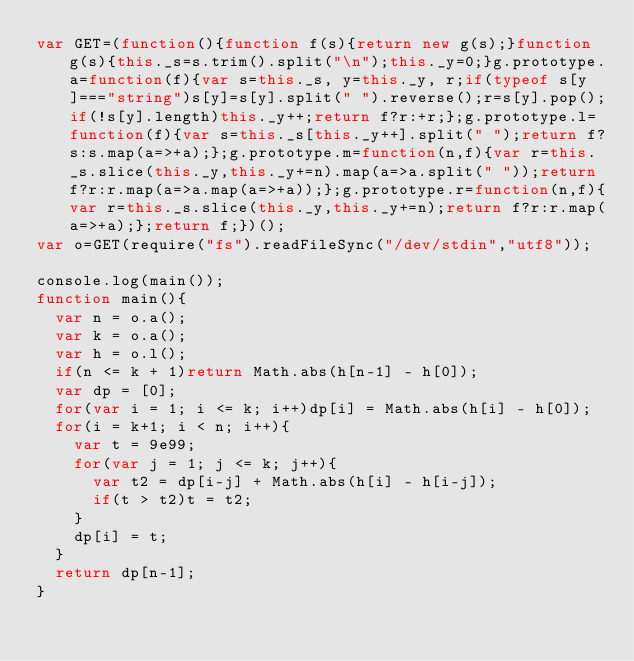<code> <loc_0><loc_0><loc_500><loc_500><_JavaScript_>var GET=(function(){function f(s){return new g(s);}function g(s){this._s=s.trim().split("\n");this._y=0;}g.prototype.a=function(f){var s=this._s, y=this._y, r;if(typeof s[y]==="string")s[y]=s[y].split(" ").reverse();r=s[y].pop();if(!s[y].length)this._y++;return f?r:+r;};g.prototype.l=function(f){var s=this._s[this._y++].split(" ");return f?s:s.map(a=>+a);};g.prototype.m=function(n,f){var r=this._s.slice(this._y,this._y+=n).map(a=>a.split(" "));return f?r:r.map(a=>a.map(a=>+a));};g.prototype.r=function(n,f){var r=this._s.slice(this._y,this._y+=n);return f?r:r.map(a=>+a);};return f;})();
var o=GET(require("fs").readFileSync("/dev/stdin","utf8"));

console.log(main());
function main(){
  var n = o.a();
  var k = o.a();
  var h = o.l();
  if(n <= k + 1)return Math.abs(h[n-1] - h[0]);
  var dp = [0];
  for(var i = 1; i <= k; i++)dp[i] = Math.abs(h[i] - h[0]);
  for(i = k+1; i < n; i++){
    var t = 9e99;
    for(var j = 1; j <= k; j++){
      var t2 = dp[i-j] + Math.abs(h[i] - h[i-j]);
      if(t > t2)t = t2;
    }
    dp[i] = t;
  }
  return dp[n-1];
}</code> 